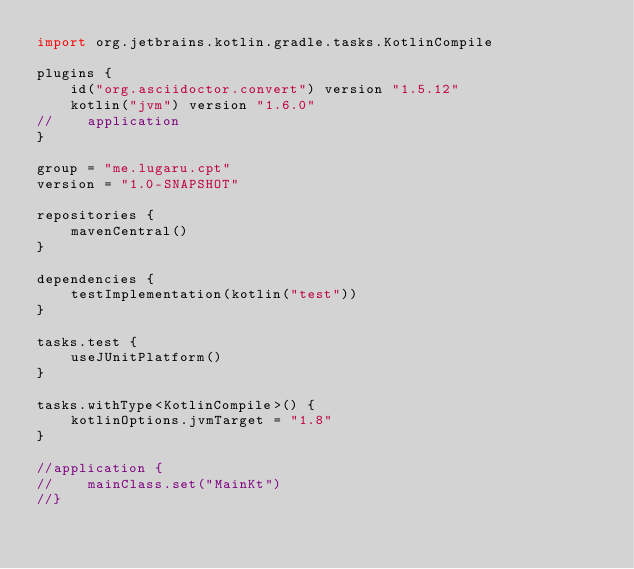<code> <loc_0><loc_0><loc_500><loc_500><_Kotlin_>import org.jetbrains.kotlin.gradle.tasks.KotlinCompile

plugins {
    id("org.asciidoctor.convert") version "1.5.12"
    kotlin("jvm") version "1.6.0"
//    application
}

group = "me.lugaru.cpt"
version = "1.0-SNAPSHOT"

repositories {
    mavenCentral()
}

dependencies {
    testImplementation(kotlin("test"))
}

tasks.test {
    useJUnitPlatform()
}

tasks.withType<KotlinCompile>() {
    kotlinOptions.jvmTarget = "1.8"
}

//application {
//    mainClass.set("MainKt")
//}</code> 